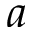Convert formula to latex. <formula><loc_0><loc_0><loc_500><loc_500>a</formula> 